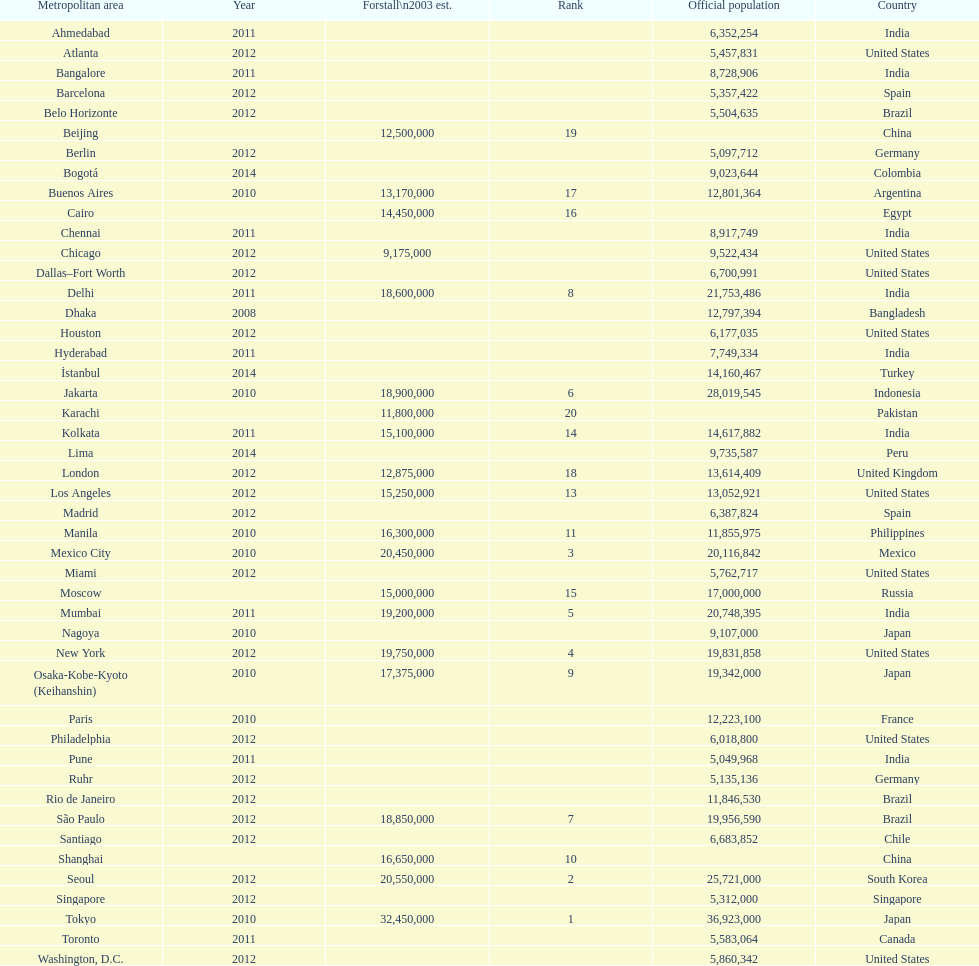Name a city from the same country as bangalore. Ahmedabad. 